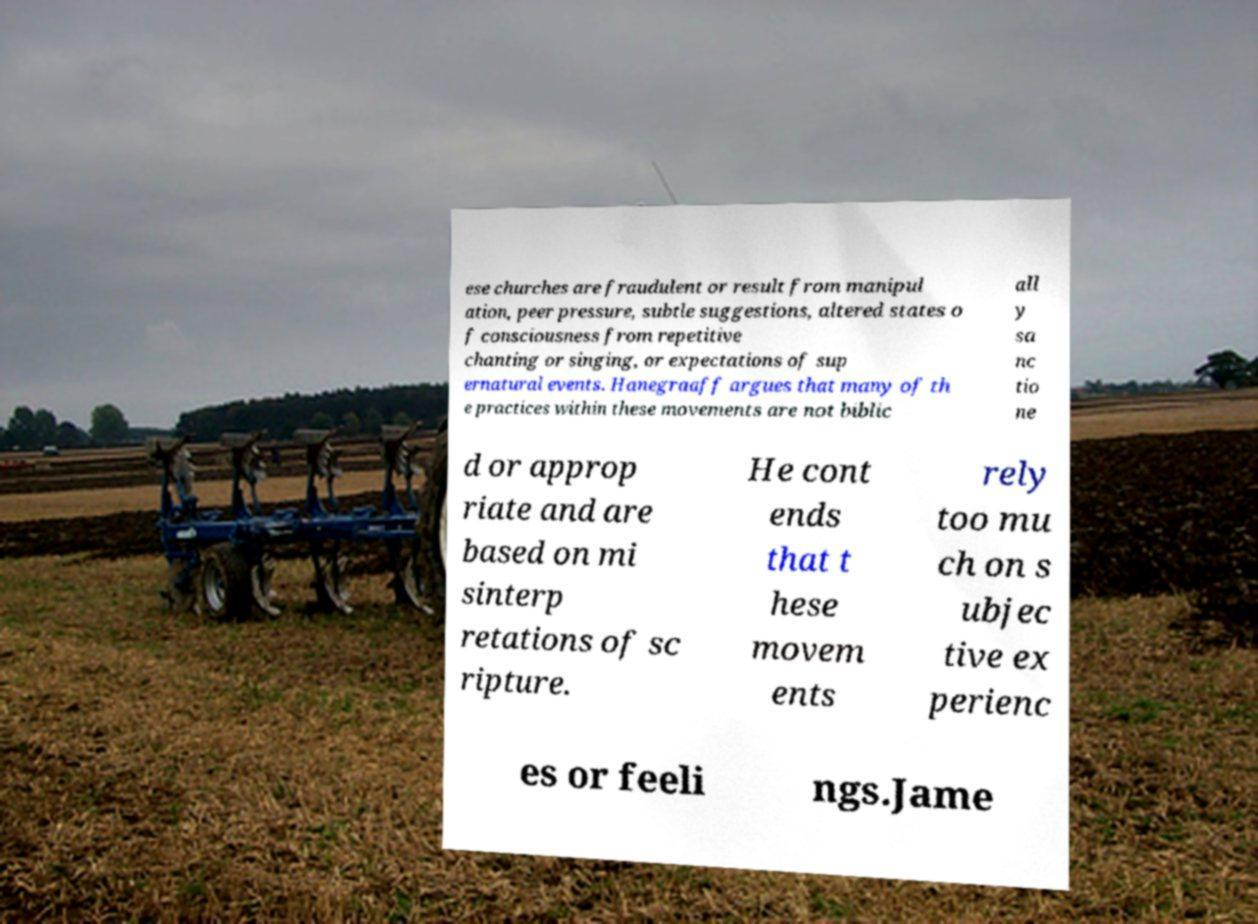For documentation purposes, I need the text within this image transcribed. Could you provide that? ese churches are fraudulent or result from manipul ation, peer pressure, subtle suggestions, altered states o f consciousness from repetitive chanting or singing, or expectations of sup ernatural events. Hanegraaff argues that many of th e practices within these movements are not biblic all y sa nc tio ne d or approp riate and are based on mi sinterp retations of sc ripture. He cont ends that t hese movem ents rely too mu ch on s ubjec tive ex perienc es or feeli ngs.Jame 